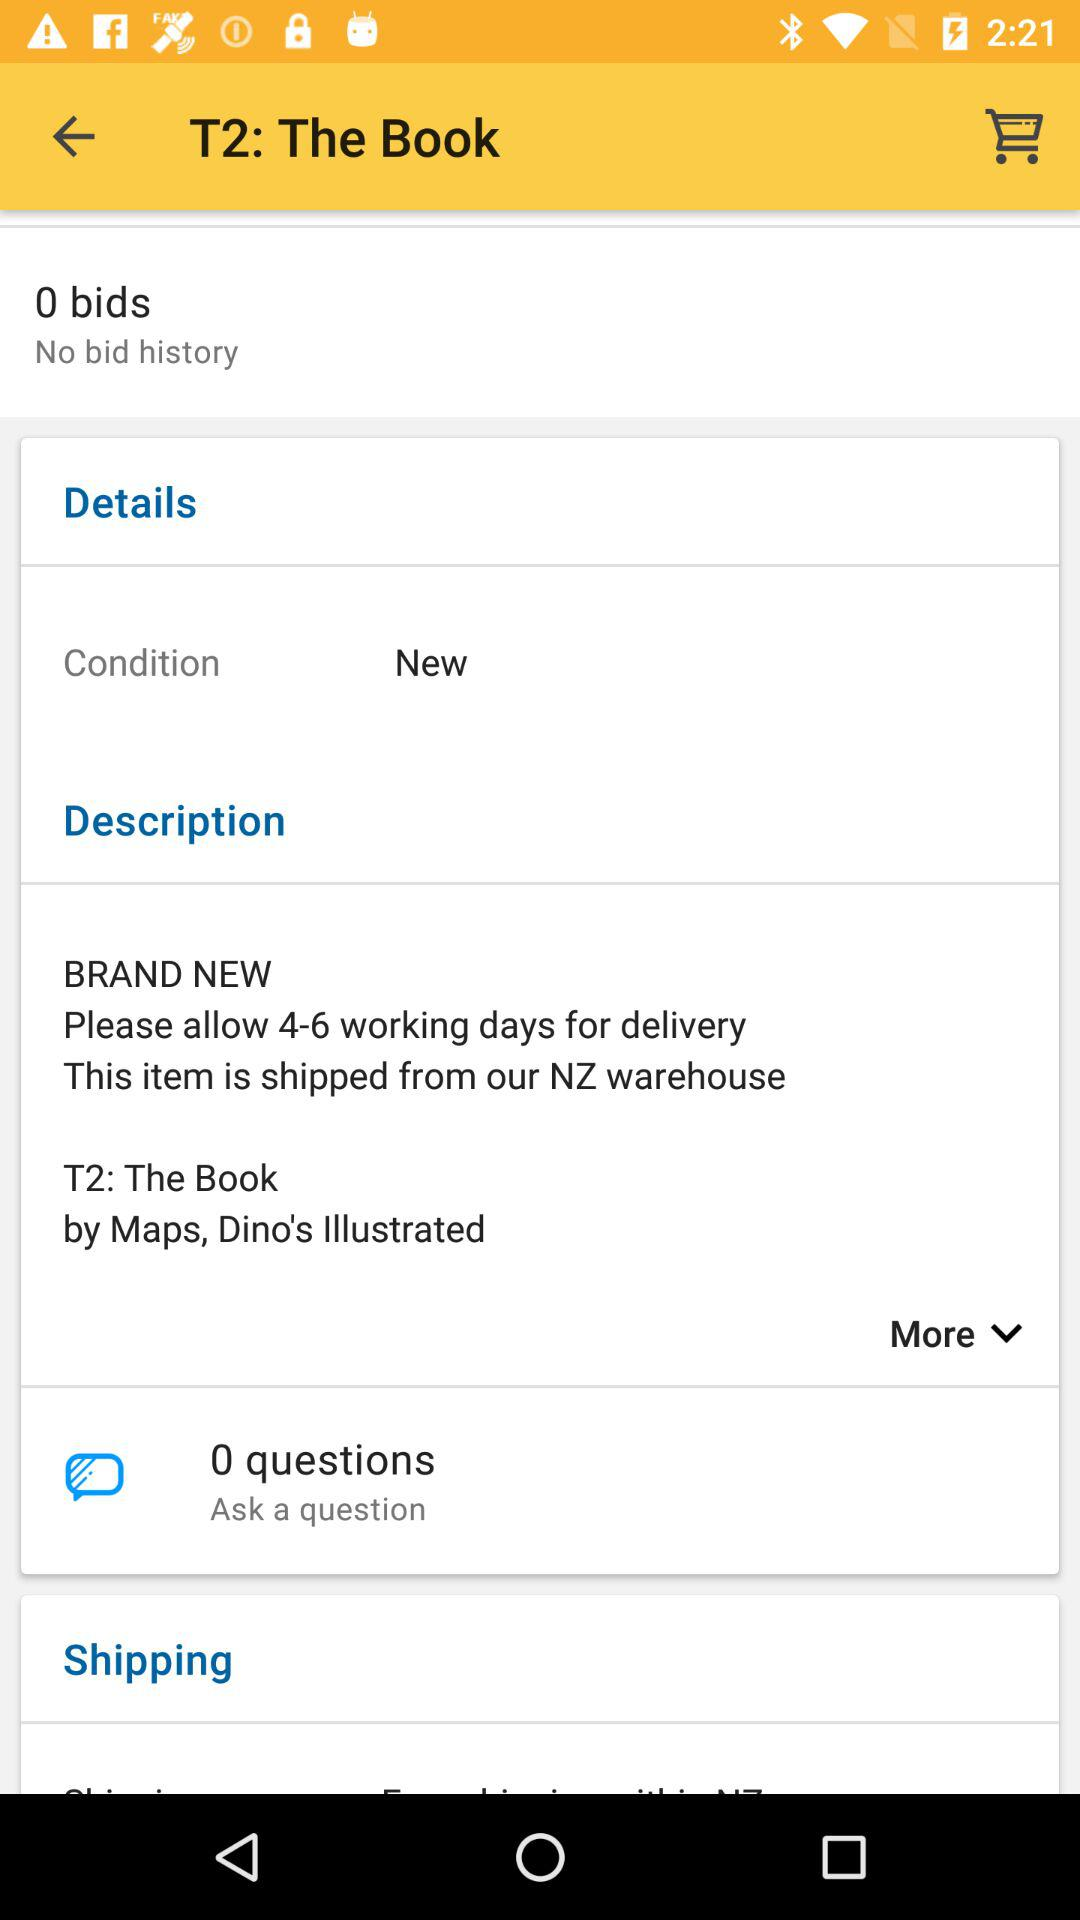How many bids are shown on the screen? There are no bids displayed for the item 'T2: The Book' on the screen, indicating that it hasn't received any bids yet. 